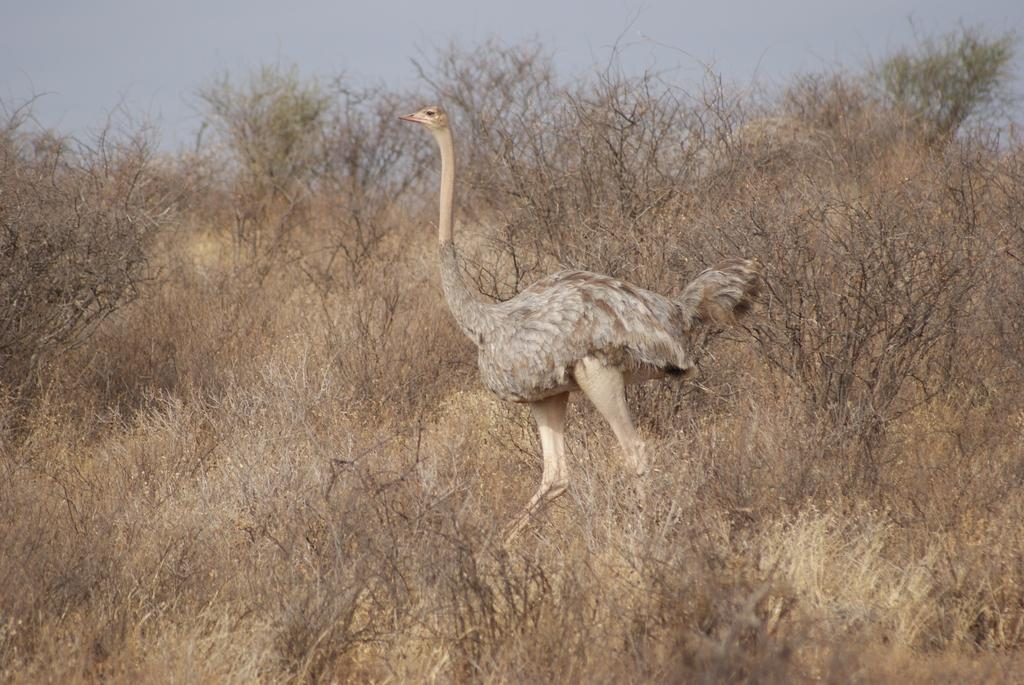What type of animal is present in the image? There is a bird in the image. Can you describe the bird's appearance? The bird has cream and brown colors. What can be seen in the background of the image? There are dry trees visible in the background. What is the color of the sky in the image? The sky is blue and white in color. What type of sweater is the bird's parent wearing in the image? There is no bird's parent or sweater present in the image. What type of plants can be seen growing near the bird in the image? There are no plants visible in the image; only dry trees are present in the background. 